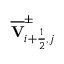<formula> <loc_0><loc_0><loc_500><loc_500>\overline { V } _ { i + \frac { 1 } { 2 } , j } ^ { \pm }</formula> 